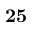Convert formula to latex. <formula><loc_0><loc_0><loc_500><loc_500>2 5</formula> 